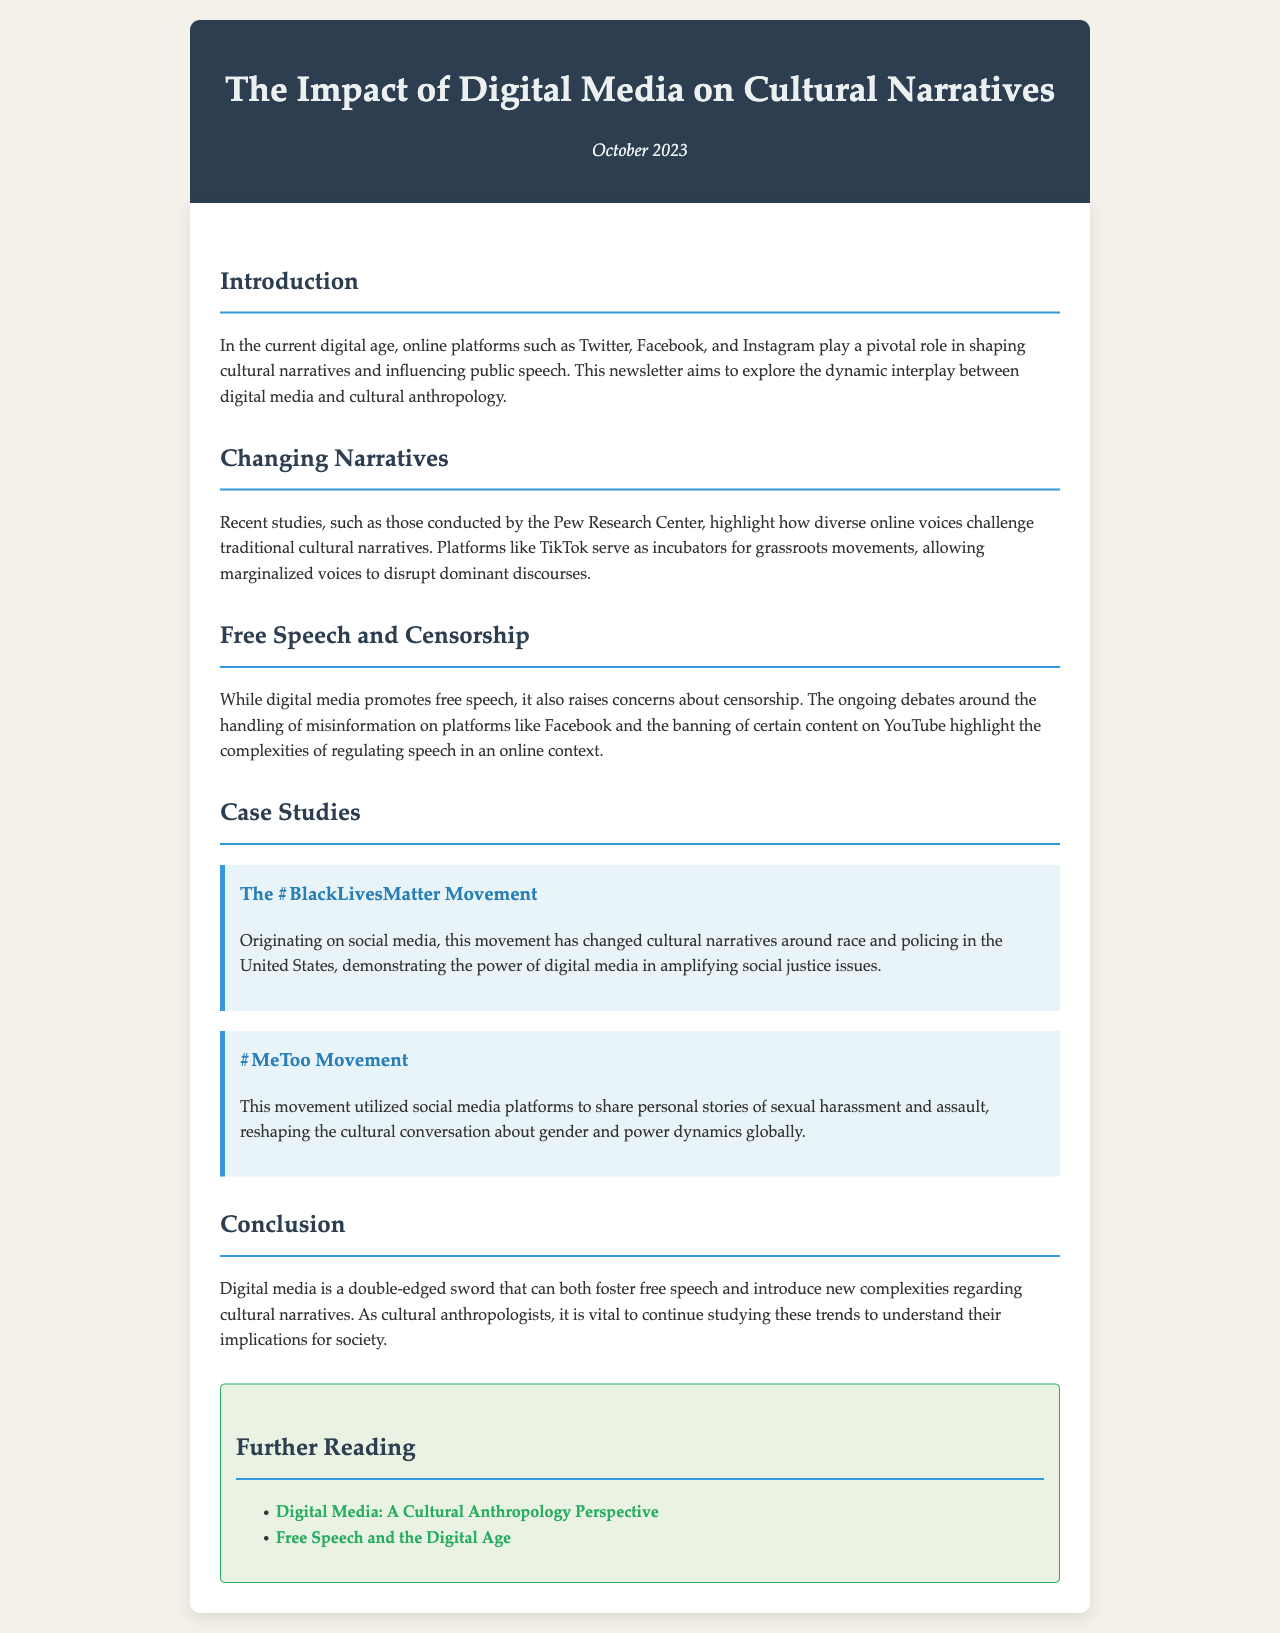what is the title of the newsletter? The title is prominently displayed at the top of the document.
Answer: The Impact of Digital Media on Cultural Narratives when was this newsletter published? The publication date is mentioned in the header section of the document.
Answer: October 2023 which organizations are mentioned as conducting studies? The document references reputable sources in the field of research.
Answer: Pew Research Center what movements are highlighted in the case studies? The case studies emphasize significant social movements that have gained attention online.
Answer: #BlackLivesMatter and #MeToo what role do online platforms play according to the introduction? The introduction outlines the influence of these platforms on cultural narratives and speech.
Answer: Pivotal role what is a key concern raised about digital media? The document discusses important issues regarding speech regulation.
Answer: Censorship how does the #MeToo movement impact cultural conversations? The case study details the movement's influence on societal issues.
Answer: Reshaping the cultural conversation about gender and power dynamics what are the two topics of further reading suggested? The newsletter provides external resources for deeper understanding.
Answer: Digital Media: A Cultural Anthropology Perspective and Free Speech and the Digital Age 